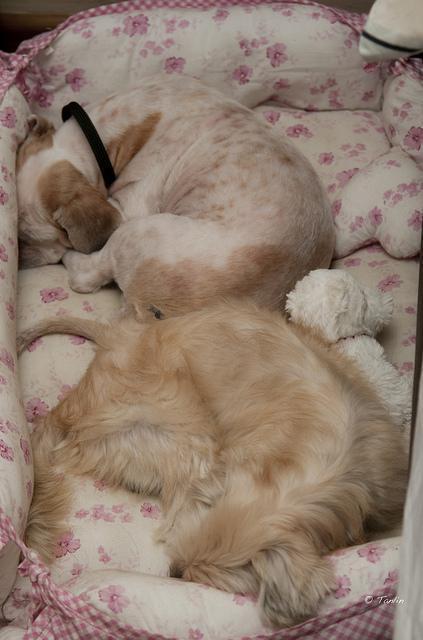How many dogs are there?
Give a very brief answer. 2. How many giraffes are shorter that the lamp post?
Give a very brief answer. 0. 